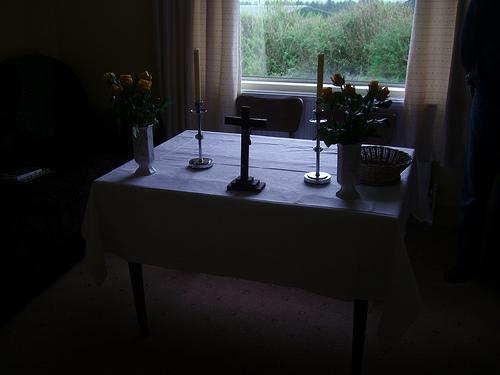How many candles are there?
Give a very brief answer. 2. 